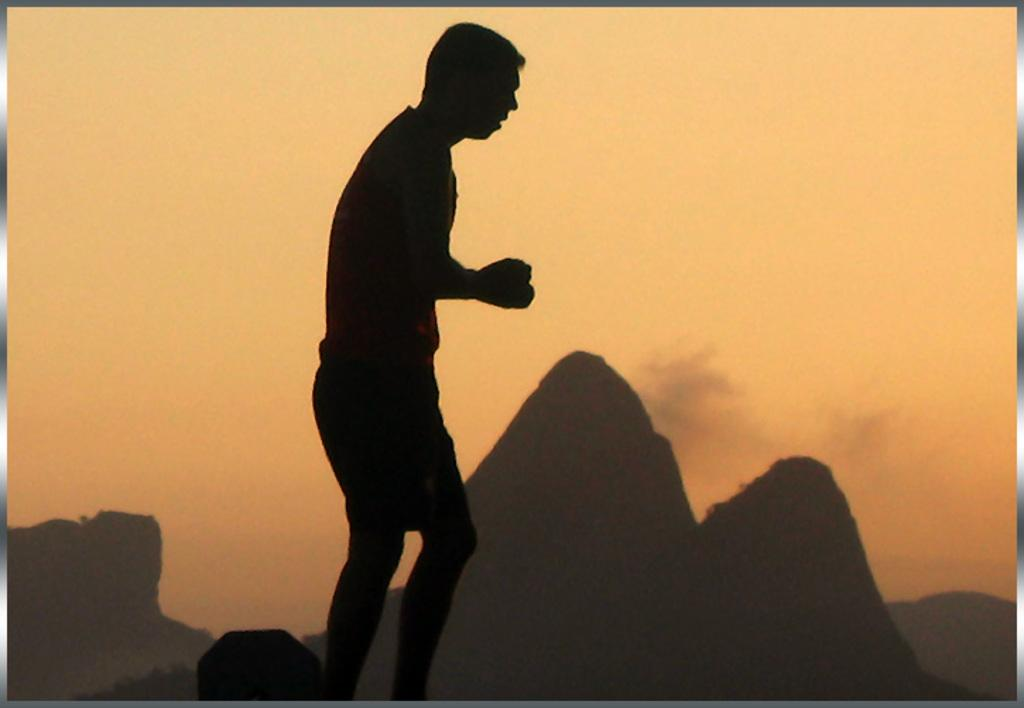What is the main subject of the image? There is a man standing in the image. Can you describe the lighting in the image? The image is dark. What can be seen in the background of the image? There are hills and the sky visible in the background of the image. What type of straw is being used to fight in the image? There is no straw or fighting present in the image; it features a man standing in a dark setting with hills and the sky visible in the background. 